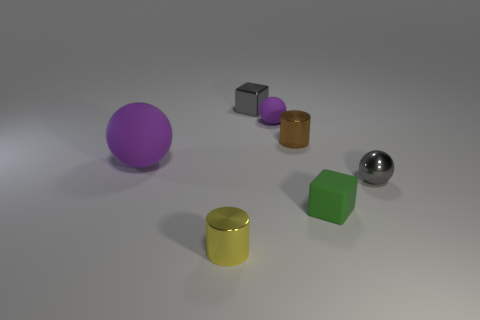The cube behind the rubber ball that is on the left side of the tiny block behind the large matte thing is what color?
Provide a short and direct response. Gray. Are there any small yellow matte things?
Make the answer very short. No. How many other things are there of the same size as the green matte thing?
Make the answer very short. 5. Is the color of the shiny block the same as the small thing that is on the left side of the tiny metallic cube?
Keep it short and to the point. No. How many objects are gray cubes or small green rubber cubes?
Your answer should be very brief. 2. Is there any other thing that is the same color as the rubber cube?
Provide a succinct answer. No. Do the gray sphere and the tiny gray thing left of the shiny ball have the same material?
Your answer should be compact. Yes. What is the shape of the object that is to the left of the tiny metal thing that is in front of the small green thing?
Provide a short and direct response. Sphere. There is a thing that is right of the tiny gray block and behind the brown cylinder; what is its shape?
Provide a succinct answer. Sphere. What number of things are small yellow rubber spheres or rubber things that are left of the tiny yellow metal thing?
Make the answer very short. 1. 